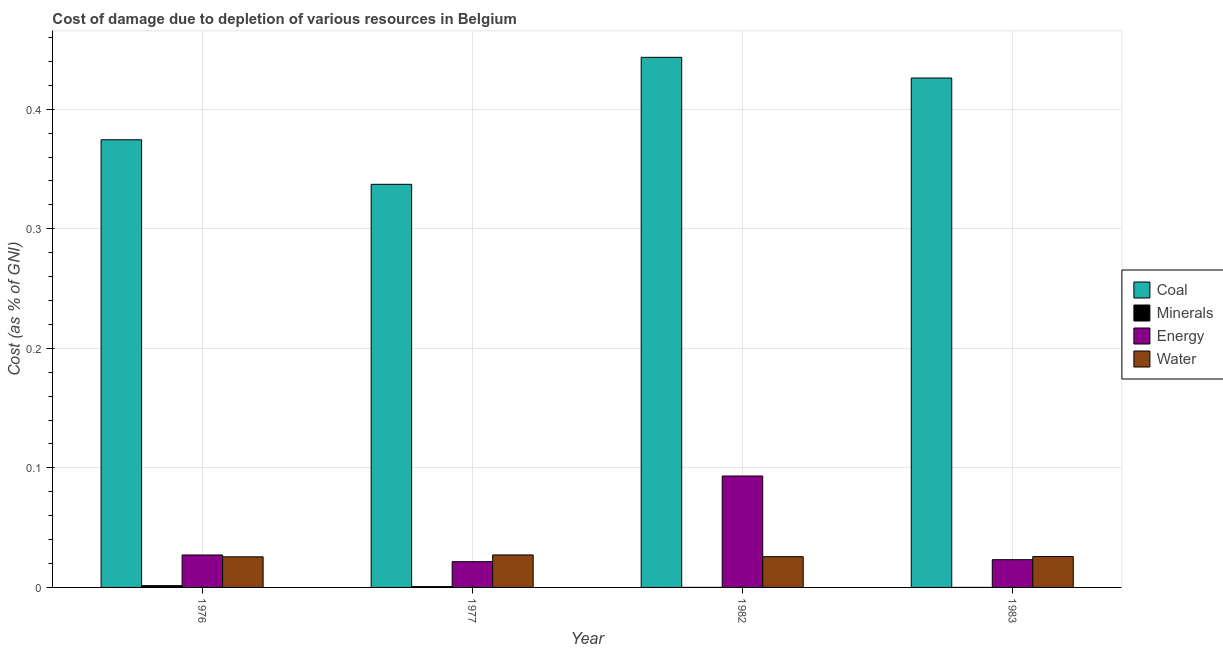How many groups of bars are there?
Give a very brief answer. 4. Are the number of bars on each tick of the X-axis equal?
Offer a very short reply. Yes. How many bars are there on the 1st tick from the left?
Provide a short and direct response. 4. What is the label of the 3rd group of bars from the left?
Offer a terse response. 1982. What is the cost of damage due to depletion of coal in 1983?
Provide a succinct answer. 0.43. Across all years, what is the maximum cost of damage due to depletion of coal?
Your answer should be compact. 0.44. Across all years, what is the minimum cost of damage due to depletion of minerals?
Make the answer very short. 1.02665016900398e-5. In which year was the cost of damage due to depletion of minerals maximum?
Your answer should be compact. 1976. What is the total cost of damage due to depletion of coal in the graph?
Give a very brief answer. 1.58. What is the difference between the cost of damage due to depletion of water in 1976 and that in 1983?
Offer a very short reply. -0. What is the difference between the cost of damage due to depletion of energy in 1976 and the cost of damage due to depletion of minerals in 1983?
Your response must be concise. 0. What is the average cost of damage due to depletion of minerals per year?
Provide a short and direct response. 0. What is the ratio of the cost of damage due to depletion of water in 1977 to that in 1982?
Your response must be concise. 1.06. What is the difference between the highest and the second highest cost of damage due to depletion of water?
Make the answer very short. 0. What is the difference between the highest and the lowest cost of damage due to depletion of energy?
Your answer should be compact. 0.07. Is the sum of the cost of damage due to depletion of energy in 1976 and 1982 greater than the maximum cost of damage due to depletion of water across all years?
Offer a terse response. Yes. Is it the case that in every year, the sum of the cost of damage due to depletion of water and cost of damage due to depletion of energy is greater than the sum of cost of damage due to depletion of minerals and cost of damage due to depletion of coal?
Provide a short and direct response. No. What does the 2nd bar from the left in 1976 represents?
Your response must be concise. Minerals. What does the 2nd bar from the right in 1982 represents?
Keep it short and to the point. Energy. Is it the case that in every year, the sum of the cost of damage due to depletion of coal and cost of damage due to depletion of minerals is greater than the cost of damage due to depletion of energy?
Your response must be concise. Yes. Are all the bars in the graph horizontal?
Offer a terse response. No. What is the difference between two consecutive major ticks on the Y-axis?
Ensure brevity in your answer.  0.1. Are the values on the major ticks of Y-axis written in scientific E-notation?
Keep it short and to the point. No. Does the graph contain any zero values?
Ensure brevity in your answer.  No. Does the graph contain grids?
Offer a very short reply. Yes. Where does the legend appear in the graph?
Offer a very short reply. Center right. What is the title of the graph?
Give a very brief answer. Cost of damage due to depletion of various resources in Belgium . Does "Ease of arranging shipments" appear as one of the legend labels in the graph?
Your response must be concise. No. What is the label or title of the Y-axis?
Ensure brevity in your answer.  Cost (as % of GNI). What is the Cost (as % of GNI) in Coal in 1976?
Give a very brief answer. 0.37. What is the Cost (as % of GNI) of Minerals in 1976?
Your answer should be very brief. 0. What is the Cost (as % of GNI) in Energy in 1976?
Ensure brevity in your answer.  0.03. What is the Cost (as % of GNI) in Water in 1976?
Your answer should be compact. 0.03. What is the Cost (as % of GNI) of Coal in 1977?
Provide a short and direct response. 0.34. What is the Cost (as % of GNI) in Minerals in 1977?
Keep it short and to the point. 0. What is the Cost (as % of GNI) of Energy in 1977?
Keep it short and to the point. 0.02. What is the Cost (as % of GNI) of Water in 1977?
Your answer should be very brief. 0.03. What is the Cost (as % of GNI) of Coal in 1982?
Offer a terse response. 0.44. What is the Cost (as % of GNI) of Minerals in 1982?
Make the answer very short. 2.31292813019687e-5. What is the Cost (as % of GNI) of Energy in 1982?
Ensure brevity in your answer.  0.09. What is the Cost (as % of GNI) in Water in 1982?
Offer a very short reply. 0.03. What is the Cost (as % of GNI) of Coal in 1983?
Offer a very short reply. 0.43. What is the Cost (as % of GNI) of Minerals in 1983?
Your answer should be very brief. 1.02665016900398e-5. What is the Cost (as % of GNI) in Energy in 1983?
Your response must be concise. 0.02. What is the Cost (as % of GNI) of Water in 1983?
Keep it short and to the point. 0.03. Across all years, what is the maximum Cost (as % of GNI) of Coal?
Your answer should be compact. 0.44. Across all years, what is the maximum Cost (as % of GNI) of Minerals?
Provide a succinct answer. 0. Across all years, what is the maximum Cost (as % of GNI) in Energy?
Provide a short and direct response. 0.09. Across all years, what is the maximum Cost (as % of GNI) in Water?
Your answer should be very brief. 0.03. Across all years, what is the minimum Cost (as % of GNI) in Coal?
Offer a very short reply. 0.34. Across all years, what is the minimum Cost (as % of GNI) in Minerals?
Offer a very short reply. 1.02665016900398e-5. Across all years, what is the minimum Cost (as % of GNI) of Energy?
Offer a very short reply. 0.02. Across all years, what is the minimum Cost (as % of GNI) of Water?
Give a very brief answer. 0.03. What is the total Cost (as % of GNI) in Coal in the graph?
Provide a short and direct response. 1.58. What is the total Cost (as % of GNI) in Minerals in the graph?
Provide a succinct answer. 0. What is the total Cost (as % of GNI) in Energy in the graph?
Give a very brief answer. 0.17. What is the total Cost (as % of GNI) in Water in the graph?
Your answer should be very brief. 0.1. What is the difference between the Cost (as % of GNI) of Coal in 1976 and that in 1977?
Your answer should be very brief. 0.04. What is the difference between the Cost (as % of GNI) in Minerals in 1976 and that in 1977?
Provide a short and direct response. 0. What is the difference between the Cost (as % of GNI) in Energy in 1976 and that in 1977?
Make the answer very short. 0.01. What is the difference between the Cost (as % of GNI) of Water in 1976 and that in 1977?
Give a very brief answer. -0. What is the difference between the Cost (as % of GNI) of Coal in 1976 and that in 1982?
Your answer should be very brief. -0.07. What is the difference between the Cost (as % of GNI) in Minerals in 1976 and that in 1982?
Keep it short and to the point. 0. What is the difference between the Cost (as % of GNI) of Energy in 1976 and that in 1982?
Provide a succinct answer. -0.07. What is the difference between the Cost (as % of GNI) of Water in 1976 and that in 1982?
Offer a terse response. -0. What is the difference between the Cost (as % of GNI) in Coal in 1976 and that in 1983?
Provide a short and direct response. -0.05. What is the difference between the Cost (as % of GNI) of Minerals in 1976 and that in 1983?
Ensure brevity in your answer.  0. What is the difference between the Cost (as % of GNI) of Energy in 1976 and that in 1983?
Offer a terse response. 0. What is the difference between the Cost (as % of GNI) in Water in 1976 and that in 1983?
Provide a short and direct response. -0. What is the difference between the Cost (as % of GNI) of Coal in 1977 and that in 1982?
Keep it short and to the point. -0.11. What is the difference between the Cost (as % of GNI) in Minerals in 1977 and that in 1982?
Provide a succinct answer. 0. What is the difference between the Cost (as % of GNI) of Energy in 1977 and that in 1982?
Provide a succinct answer. -0.07. What is the difference between the Cost (as % of GNI) of Water in 1977 and that in 1982?
Keep it short and to the point. 0. What is the difference between the Cost (as % of GNI) of Coal in 1977 and that in 1983?
Provide a succinct answer. -0.09. What is the difference between the Cost (as % of GNI) of Minerals in 1977 and that in 1983?
Provide a short and direct response. 0. What is the difference between the Cost (as % of GNI) of Energy in 1977 and that in 1983?
Your response must be concise. -0. What is the difference between the Cost (as % of GNI) in Water in 1977 and that in 1983?
Your response must be concise. 0. What is the difference between the Cost (as % of GNI) in Coal in 1982 and that in 1983?
Your response must be concise. 0.02. What is the difference between the Cost (as % of GNI) in Energy in 1982 and that in 1983?
Your response must be concise. 0.07. What is the difference between the Cost (as % of GNI) of Water in 1982 and that in 1983?
Offer a terse response. -0. What is the difference between the Cost (as % of GNI) in Coal in 1976 and the Cost (as % of GNI) in Minerals in 1977?
Make the answer very short. 0.37. What is the difference between the Cost (as % of GNI) in Coal in 1976 and the Cost (as % of GNI) in Energy in 1977?
Keep it short and to the point. 0.35. What is the difference between the Cost (as % of GNI) of Coal in 1976 and the Cost (as % of GNI) of Water in 1977?
Keep it short and to the point. 0.35. What is the difference between the Cost (as % of GNI) in Minerals in 1976 and the Cost (as % of GNI) in Energy in 1977?
Offer a terse response. -0.02. What is the difference between the Cost (as % of GNI) of Minerals in 1976 and the Cost (as % of GNI) of Water in 1977?
Your answer should be compact. -0.03. What is the difference between the Cost (as % of GNI) in Coal in 1976 and the Cost (as % of GNI) in Minerals in 1982?
Your answer should be compact. 0.37. What is the difference between the Cost (as % of GNI) in Coal in 1976 and the Cost (as % of GNI) in Energy in 1982?
Offer a terse response. 0.28. What is the difference between the Cost (as % of GNI) in Coal in 1976 and the Cost (as % of GNI) in Water in 1982?
Your response must be concise. 0.35. What is the difference between the Cost (as % of GNI) of Minerals in 1976 and the Cost (as % of GNI) of Energy in 1982?
Your answer should be very brief. -0.09. What is the difference between the Cost (as % of GNI) of Minerals in 1976 and the Cost (as % of GNI) of Water in 1982?
Give a very brief answer. -0.02. What is the difference between the Cost (as % of GNI) of Energy in 1976 and the Cost (as % of GNI) of Water in 1982?
Keep it short and to the point. 0. What is the difference between the Cost (as % of GNI) in Coal in 1976 and the Cost (as % of GNI) in Minerals in 1983?
Your response must be concise. 0.37. What is the difference between the Cost (as % of GNI) in Coal in 1976 and the Cost (as % of GNI) in Energy in 1983?
Your answer should be compact. 0.35. What is the difference between the Cost (as % of GNI) of Coal in 1976 and the Cost (as % of GNI) of Water in 1983?
Your answer should be very brief. 0.35. What is the difference between the Cost (as % of GNI) in Minerals in 1976 and the Cost (as % of GNI) in Energy in 1983?
Provide a succinct answer. -0.02. What is the difference between the Cost (as % of GNI) of Minerals in 1976 and the Cost (as % of GNI) of Water in 1983?
Offer a very short reply. -0.02. What is the difference between the Cost (as % of GNI) of Energy in 1976 and the Cost (as % of GNI) of Water in 1983?
Provide a succinct answer. 0. What is the difference between the Cost (as % of GNI) in Coal in 1977 and the Cost (as % of GNI) in Minerals in 1982?
Ensure brevity in your answer.  0.34. What is the difference between the Cost (as % of GNI) in Coal in 1977 and the Cost (as % of GNI) in Energy in 1982?
Provide a succinct answer. 0.24. What is the difference between the Cost (as % of GNI) of Coal in 1977 and the Cost (as % of GNI) of Water in 1982?
Ensure brevity in your answer.  0.31. What is the difference between the Cost (as % of GNI) of Minerals in 1977 and the Cost (as % of GNI) of Energy in 1982?
Ensure brevity in your answer.  -0.09. What is the difference between the Cost (as % of GNI) in Minerals in 1977 and the Cost (as % of GNI) in Water in 1982?
Your response must be concise. -0.03. What is the difference between the Cost (as % of GNI) in Energy in 1977 and the Cost (as % of GNI) in Water in 1982?
Make the answer very short. -0. What is the difference between the Cost (as % of GNI) in Coal in 1977 and the Cost (as % of GNI) in Minerals in 1983?
Provide a short and direct response. 0.34. What is the difference between the Cost (as % of GNI) in Coal in 1977 and the Cost (as % of GNI) in Energy in 1983?
Give a very brief answer. 0.31. What is the difference between the Cost (as % of GNI) of Coal in 1977 and the Cost (as % of GNI) of Water in 1983?
Give a very brief answer. 0.31. What is the difference between the Cost (as % of GNI) of Minerals in 1977 and the Cost (as % of GNI) of Energy in 1983?
Keep it short and to the point. -0.02. What is the difference between the Cost (as % of GNI) in Minerals in 1977 and the Cost (as % of GNI) in Water in 1983?
Your response must be concise. -0.03. What is the difference between the Cost (as % of GNI) in Energy in 1977 and the Cost (as % of GNI) in Water in 1983?
Make the answer very short. -0. What is the difference between the Cost (as % of GNI) of Coal in 1982 and the Cost (as % of GNI) of Minerals in 1983?
Your response must be concise. 0.44. What is the difference between the Cost (as % of GNI) in Coal in 1982 and the Cost (as % of GNI) in Energy in 1983?
Your answer should be very brief. 0.42. What is the difference between the Cost (as % of GNI) of Coal in 1982 and the Cost (as % of GNI) of Water in 1983?
Make the answer very short. 0.42. What is the difference between the Cost (as % of GNI) of Minerals in 1982 and the Cost (as % of GNI) of Energy in 1983?
Your response must be concise. -0.02. What is the difference between the Cost (as % of GNI) of Minerals in 1982 and the Cost (as % of GNI) of Water in 1983?
Your answer should be very brief. -0.03. What is the difference between the Cost (as % of GNI) of Energy in 1982 and the Cost (as % of GNI) of Water in 1983?
Keep it short and to the point. 0.07. What is the average Cost (as % of GNI) of Coal per year?
Provide a short and direct response. 0.4. What is the average Cost (as % of GNI) in Minerals per year?
Your answer should be very brief. 0. What is the average Cost (as % of GNI) of Energy per year?
Your answer should be compact. 0.04. What is the average Cost (as % of GNI) of Water per year?
Provide a succinct answer. 0.03. In the year 1976, what is the difference between the Cost (as % of GNI) in Coal and Cost (as % of GNI) in Minerals?
Keep it short and to the point. 0.37. In the year 1976, what is the difference between the Cost (as % of GNI) in Coal and Cost (as % of GNI) in Energy?
Your response must be concise. 0.35. In the year 1976, what is the difference between the Cost (as % of GNI) of Coal and Cost (as % of GNI) of Water?
Offer a very short reply. 0.35. In the year 1976, what is the difference between the Cost (as % of GNI) in Minerals and Cost (as % of GNI) in Energy?
Provide a succinct answer. -0.03. In the year 1976, what is the difference between the Cost (as % of GNI) in Minerals and Cost (as % of GNI) in Water?
Keep it short and to the point. -0.02. In the year 1976, what is the difference between the Cost (as % of GNI) of Energy and Cost (as % of GNI) of Water?
Provide a succinct answer. 0. In the year 1977, what is the difference between the Cost (as % of GNI) in Coal and Cost (as % of GNI) in Minerals?
Your response must be concise. 0.34. In the year 1977, what is the difference between the Cost (as % of GNI) of Coal and Cost (as % of GNI) of Energy?
Make the answer very short. 0.32. In the year 1977, what is the difference between the Cost (as % of GNI) of Coal and Cost (as % of GNI) of Water?
Provide a succinct answer. 0.31. In the year 1977, what is the difference between the Cost (as % of GNI) in Minerals and Cost (as % of GNI) in Energy?
Offer a terse response. -0.02. In the year 1977, what is the difference between the Cost (as % of GNI) in Minerals and Cost (as % of GNI) in Water?
Make the answer very short. -0.03. In the year 1977, what is the difference between the Cost (as % of GNI) of Energy and Cost (as % of GNI) of Water?
Your answer should be very brief. -0.01. In the year 1982, what is the difference between the Cost (as % of GNI) in Coal and Cost (as % of GNI) in Minerals?
Provide a succinct answer. 0.44. In the year 1982, what is the difference between the Cost (as % of GNI) of Coal and Cost (as % of GNI) of Energy?
Your response must be concise. 0.35. In the year 1982, what is the difference between the Cost (as % of GNI) in Coal and Cost (as % of GNI) in Water?
Offer a terse response. 0.42. In the year 1982, what is the difference between the Cost (as % of GNI) in Minerals and Cost (as % of GNI) in Energy?
Offer a terse response. -0.09. In the year 1982, what is the difference between the Cost (as % of GNI) of Minerals and Cost (as % of GNI) of Water?
Offer a very short reply. -0.03. In the year 1982, what is the difference between the Cost (as % of GNI) in Energy and Cost (as % of GNI) in Water?
Your response must be concise. 0.07. In the year 1983, what is the difference between the Cost (as % of GNI) in Coal and Cost (as % of GNI) in Minerals?
Ensure brevity in your answer.  0.43. In the year 1983, what is the difference between the Cost (as % of GNI) of Coal and Cost (as % of GNI) of Energy?
Ensure brevity in your answer.  0.4. In the year 1983, what is the difference between the Cost (as % of GNI) in Coal and Cost (as % of GNI) in Water?
Your answer should be compact. 0.4. In the year 1983, what is the difference between the Cost (as % of GNI) of Minerals and Cost (as % of GNI) of Energy?
Your answer should be very brief. -0.02. In the year 1983, what is the difference between the Cost (as % of GNI) in Minerals and Cost (as % of GNI) in Water?
Provide a succinct answer. -0.03. In the year 1983, what is the difference between the Cost (as % of GNI) of Energy and Cost (as % of GNI) of Water?
Your response must be concise. -0. What is the ratio of the Cost (as % of GNI) of Coal in 1976 to that in 1977?
Give a very brief answer. 1.11. What is the ratio of the Cost (as % of GNI) in Minerals in 1976 to that in 1977?
Provide a succinct answer. 2.17. What is the ratio of the Cost (as % of GNI) of Energy in 1976 to that in 1977?
Provide a short and direct response. 1.26. What is the ratio of the Cost (as % of GNI) of Water in 1976 to that in 1977?
Provide a short and direct response. 0.94. What is the ratio of the Cost (as % of GNI) of Coal in 1976 to that in 1982?
Give a very brief answer. 0.84. What is the ratio of the Cost (as % of GNI) of Minerals in 1976 to that in 1982?
Keep it short and to the point. 64.57. What is the ratio of the Cost (as % of GNI) of Energy in 1976 to that in 1982?
Provide a short and direct response. 0.29. What is the ratio of the Cost (as % of GNI) in Water in 1976 to that in 1982?
Your answer should be compact. 1. What is the ratio of the Cost (as % of GNI) in Coal in 1976 to that in 1983?
Your response must be concise. 0.88. What is the ratio of the Cost (as % of GNI) of Minerals in 1976 to that in 1983?
Ensure brevity in your answer.  145.48. What is the ratio of the Cost (as % of GNI) in Energy in 1976 to that in 1983?
Make the answer very short. 1.17. What is the ratio of the Cost (as % of GNI) of Water in 1976 to that in 1983?
Give a very brief answer. 0.99. What is the ratio of the Cost (as % of GNI) of Coal in 1977 to that in 1982?
Make the answer very short. 0.76. What is the ratio of the Cost (as % of GNI) of Minerals in 1977 to that in 1982?
Offer a terse response. 29.73. What is the ratio of the Cost (as % of GNI) of Energy in 1977 to that in 1982?
Make the answer very short. 0.23. What is the ratio of the Cost (as % of GNI) in Water in 1977 to that in 1982?
Provide a succinct answer. 1.06. What is the ratio of the Cost (as % of GNI) in Coal in 1977 to that in 1983?
Offer a very short reply. 0.79. What is the ratio of the Cost (as % of GNI) of Minerals in 1977 to that in 1983?
Provide a succinct answer. 66.97. What is the ratio of the Cost (as % of GNI) in Energy in 1977 to that in 1983?
Provide a short and direct response. 0.93. What is the ratio of the Cost (as % of GNI) of Water in 1977 to that in 1983?
Offer a very short reply. 1.05. What is the ratio of the Cost (as % of GNI) of Coal in 1982 to that in 1983?
Offer a very short reply. 1.04. What is the ratio of the Cost (as % of GNI) of Minerals in 1982 to that in 1983?
Keep it short and to the point. 2.25. What is the ratio of the Cost (as % of GNI) in Energy in 1982 to that in 1983?
Your answer should be compact. 4.02. What is the ratio of the Cost (as % of GNI) in Water in 1982 to that in 1983?
Provide a short and direct response. 1. What is the difference between the highest and the second highest Cost (as % of GNI) of Coal?
Keep it short and to the point. 0.02. What is the difference between the highest and the second highest Cost (as % of GNI) of Minerals?
Your answer should be compact. 0. What is the difference between the highest and the second highest Cost (as % of GNI) in Energy?
Offer a terse response. 0.07. What is the difference between the highest and the second highest Cost (as % of GNI) in Water?
Your response must be concise. 0. What is the difference between the highest and the lowest Cost (as % of GNI) of Coal?
Your answer should be very brief. 0.11. What is the difference between the highest and the lowest Cost (as % of GNI) in Minerals?
Offer a very short reply. 0. What is the difference between the highest and the lowest Cost (as % of GNI) of Energy?
Ensure brevity in your answer.  0.07. What is the difference between the highest and the lowest Cost (as % of GNI) of Water?
Your response must be concise. 0. 